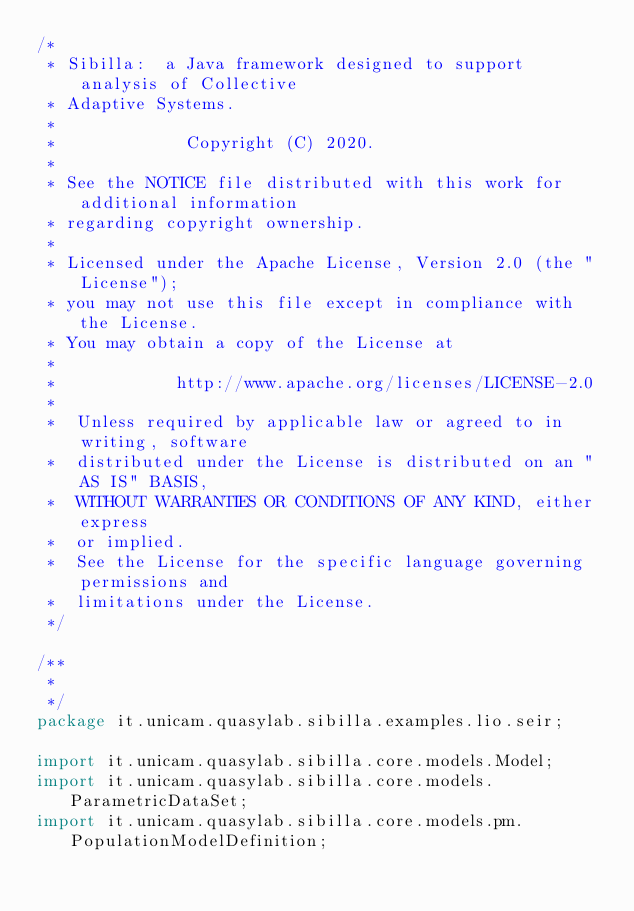<code> <loc_0><loc_0><loc_500><loc_500><_Java_>/*
 * Sibilla:  a Java framework designed to support analysis of Collective
 * Adaptive Systems.
 *
 *             Copyright (C) 2020.
 *
 * See the NOTICE file distributed with this work for additional information
 * regarding copyright ownership.
 *
 * Licensed under the Apache License, Version 2.0 (the "License");
 * you may not use this file except in compliance with the License.
 * You may obtain a copy of the License at
 *
 *            http://www.apache.org/licenses/LICENSE-2.0
 *
 *  Unless required by applicable law or agreed to in writing, software
 *  distributed under the License is distributed on an "AS IS" BASIS,
 *  WITHOUT WARRANTIES OR CONDITIONS OF ANY KIND, either express
 *  or implied.
 *  See the License for the specific language governing permissions and
 *  limitations under the License.
 */

/**
 *
 */
package it.unicam.quasylab.sibilla.examples.lio.seir;

import it.unicam.quasylab.sibilla.core.models.Model;
import it.unicam.quasylab.sibilla.core.models.ParametricDataSet;
import it.unicam.quasylab.sibilla.core.models.pm.PopulationModelDefinition;</code> 